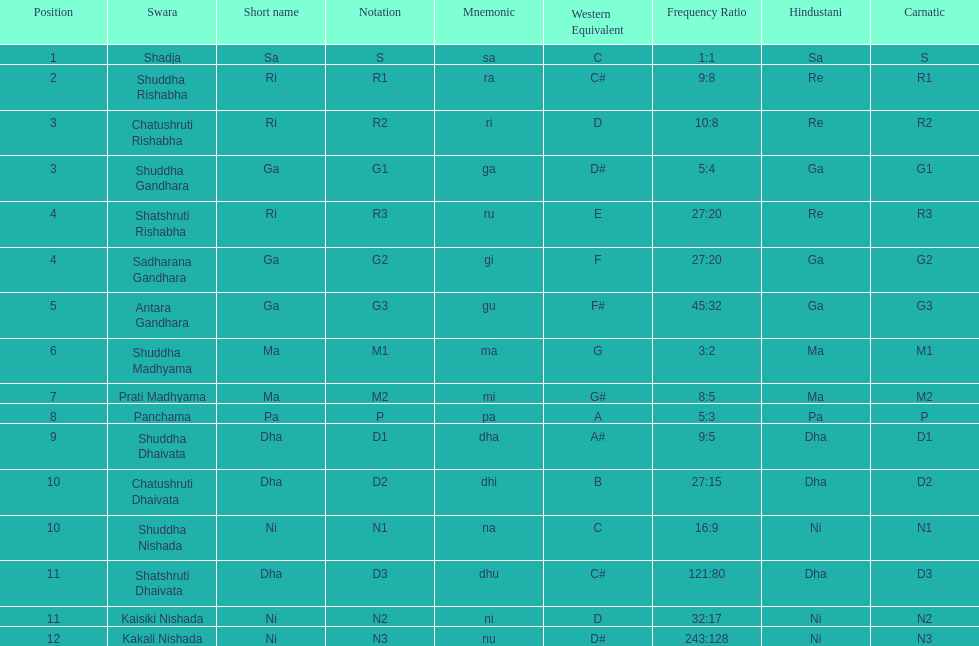Find the 9th position swara. what is its short name? Dha. 